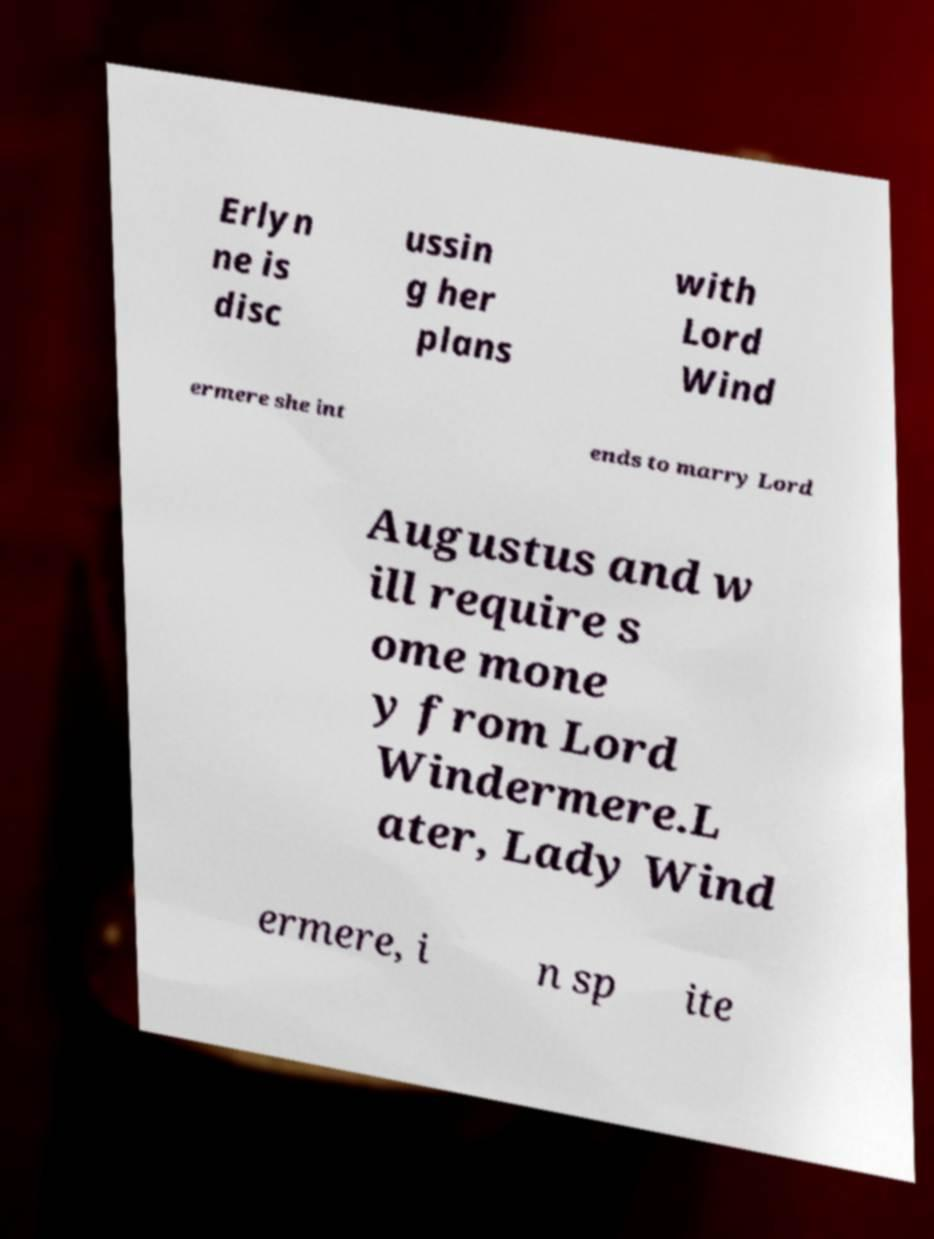What messages or text are displayed in this image? I need them in a readable, typed format. Erlyn ne is disc ussin g her plans with Lord Wind ermere she int ends to marry Lord Augustus and w ill require s ome mone y from Lord Windermere.L ater, Lady Wind ermere, i n sp ite 